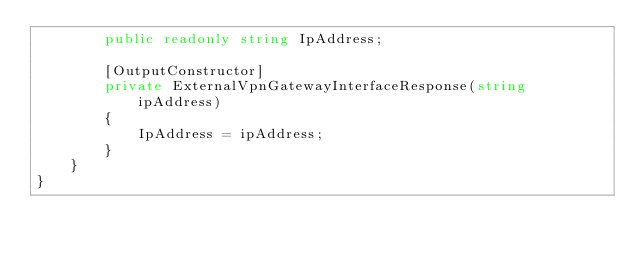Convert code to text. <code><loc_0><loc_0><loc_500><loc_500><_C#_>        public readonly string IpAddress;

        [OutputConstructor]
        private ExternalVpnGatewayInterfaceResponse(string ipAddress)
        {
            IpAddress = ipAddress;
        }
    }
}
</code> 